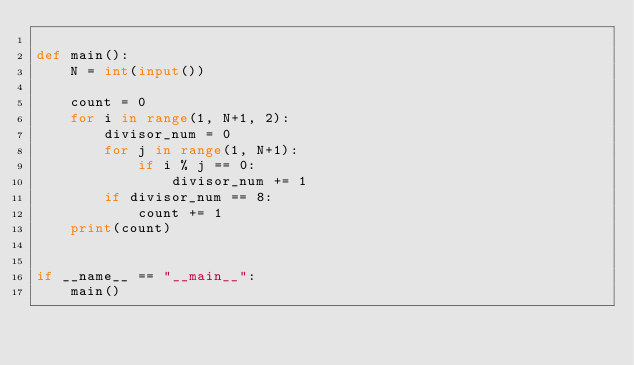Convert code to text. <code><loc_0><loc_0><loc_500><loc_500><_Python_>
def main():
    N = int(input())

    count = 0
    for i in range(1, N+1, 2):
        divisor_num = 0
        for j in range(1, N+1):
            if i % j == 0:
                divisor_num += 1
        if divisor_num == 8:
            count += 1
    print(count)


if __name__ == "__main__":
    main()
</code> 